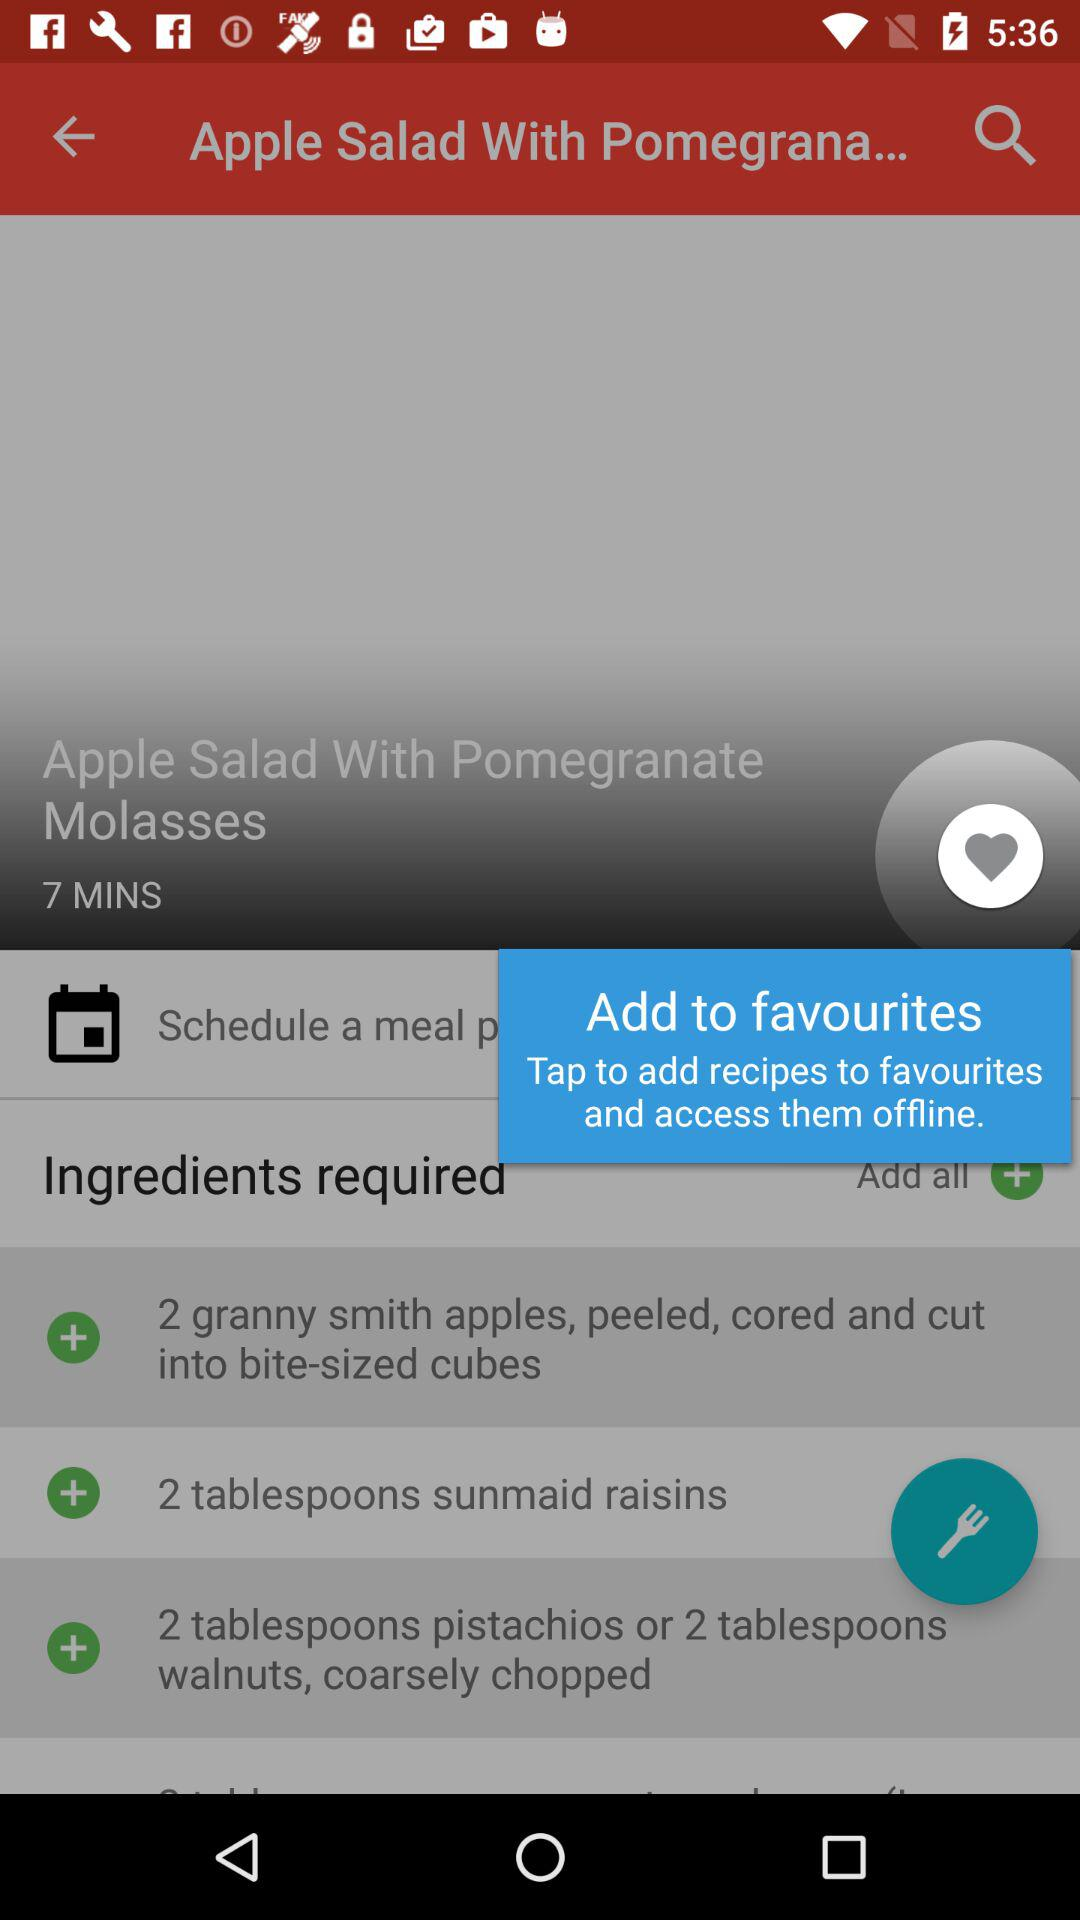What's the preparation time for "Apple Salad with Pomegranate Molasses"? The preparation time is 7 minutes. 